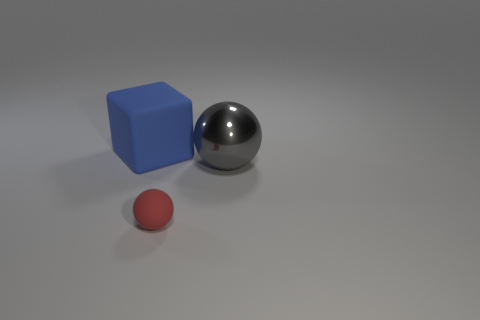Is there anything else that has the same size as the red rubber thing?
Offer a very short reply. No. Is there a gray shiny thing that has the same shape as the red matte thing?
Your answer should be compact. Yes. There is a object that is the same size as the matte cube; what is its shape?
Your response must be concise. Sphere. What is the material of the large ball?
Provide a succinct answer. Metal. How big is the matte thing right of the rubber object that is to the left of the matte object that is to the right of the big rubber object?
Ensure brevity in your answer.  Small. How many metal things are either small green cubes or blue blocks?
Make the answer very short. 0. The gray shiny ball is what size?
Keep it short and to the point. Large. How many things are either rubber spheres or big things on the left side of the red matte sphere?
Your response must be concise. 2. How many other objects are there of the same color as the metallic object?
Provide a succinct answer. 0. There is a gray metal ball; is it the same size as the rubber object that is on the right side of the blue rubber block?
Ensure brevity in your answer.  No. 